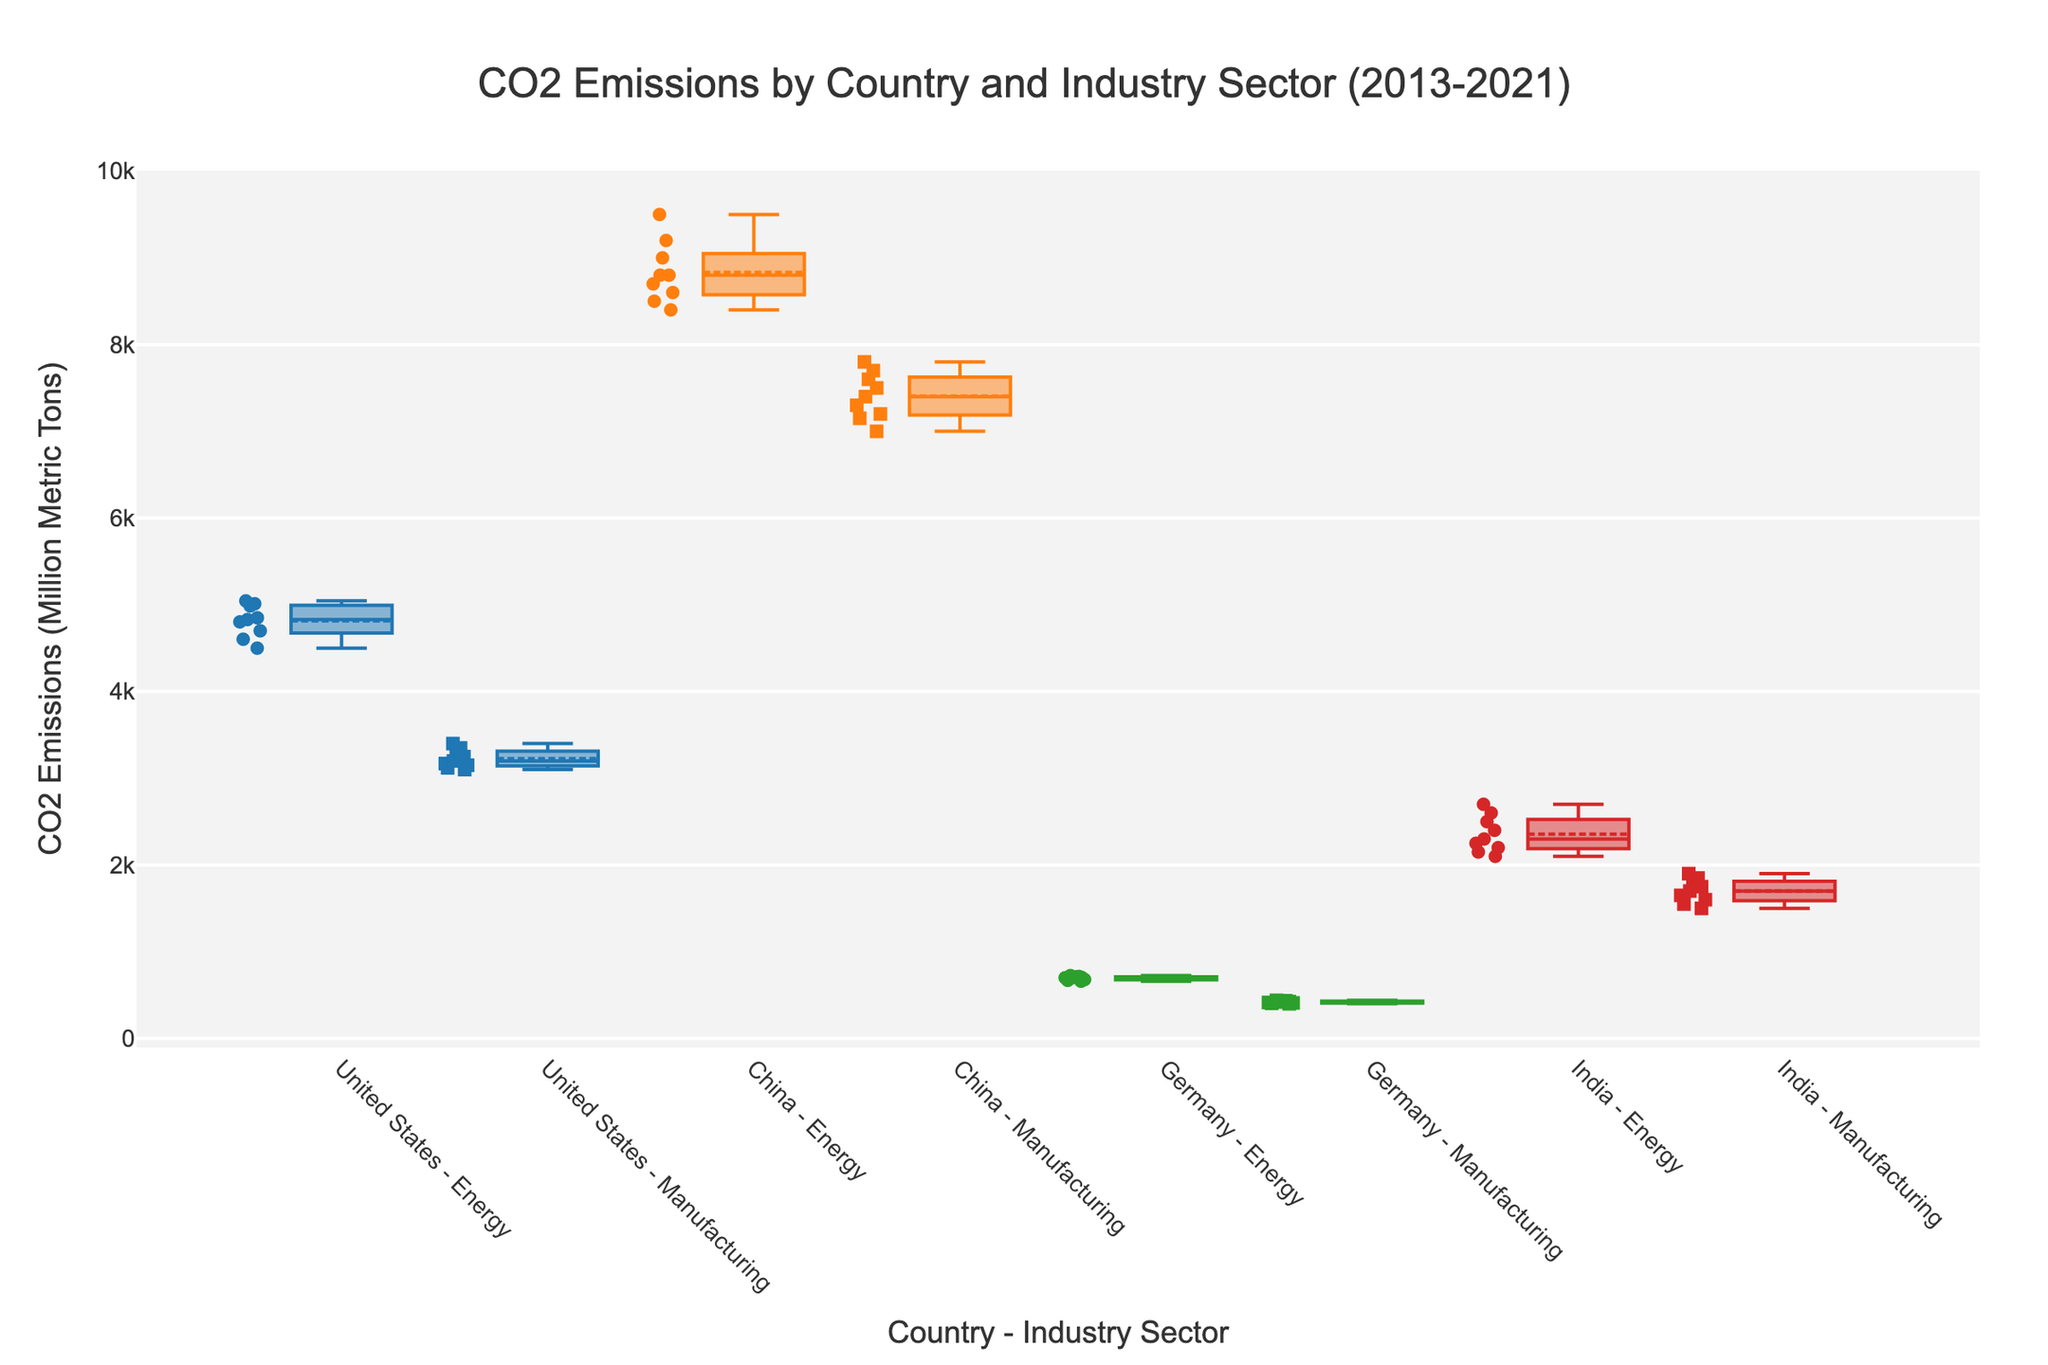What's the title of the figure? The title is usually located at the top of the figure.
Answer: CO2 Emissions by Country and Industry Sector (2013-2021) Which country has the highest median CO2 emissions in the energy sector? To determine the highest median, identify the medians for each country in the energy sector and compare them.
Answer: China What is the main color used for representing CO2 emissions in Germany? Observe the color used in the box plots and scatter points associated with 'Germany' in the legend or elsewhere in the figure.
Answer: Green Are CO2 emissions from the manufacturing sector for any country higher than those from the energy sector? Compare the box plots and scatter points for the manufacturing and energy sectors for each country.
Answer: Yes, for China How many unique industry sectors are represented in the figure? Count the distinct symbols or legends used to represent different industry sectors.
Answer: Two What is the range of CO2 emissions for the United States in the energy sector? Identify the minimum and maximum data points within the box plot for the United States - Energy.
Answer: 4500 to 5045 Which industry sector generally shows higher CO2 emissions for India, energy or manufacturing? Compare the box plots for India in both the energy and manufacturing sectors to see which has higher medians and ranges.
Answer: Energy What can you say about the variation in CO2 emissions in China's energy and manufacturing sectors? Assess the spread of the data points within the box plots for both sectors in China to understand their variability.
Answer: Both show high variability, but energy has a wider range Which country shows the least variability in CO2 emissions in the manufacturing sector? Identify the box plot with the smallest interquartile range (IQR) for the manufacturing sector.
Answer: Germany Between 2013 and 2021, which sector shows a decreasing trend in CO2 emissions for Germany? Observe the scatter points' general trend within each box plot for Germany's sectors.
Answer: Energy 